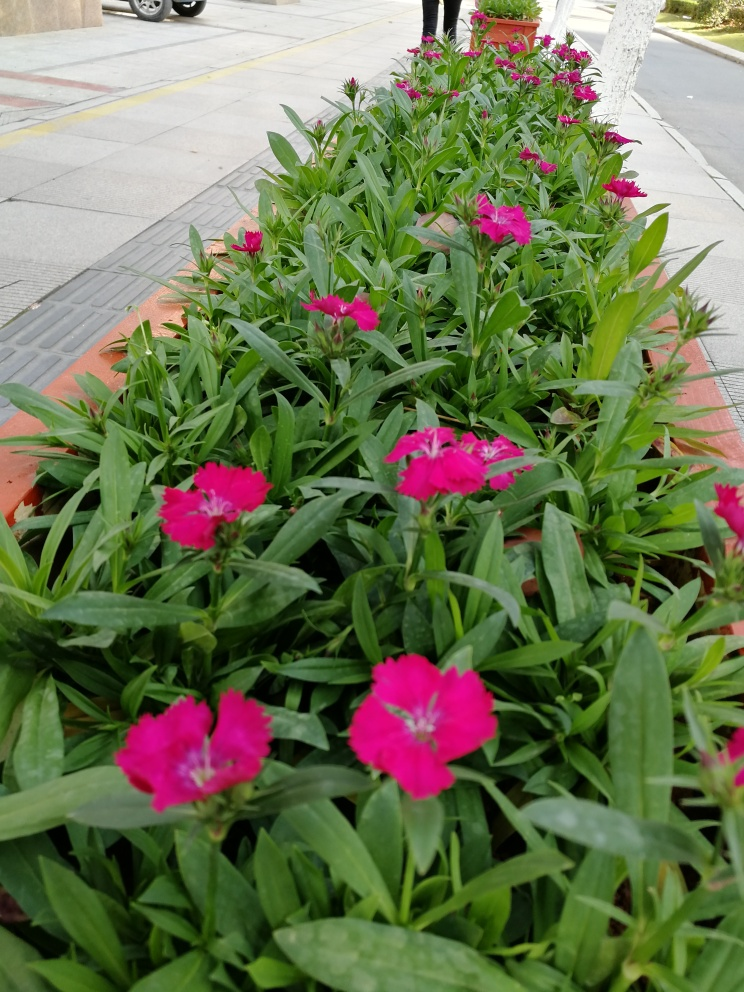Are there any quality issues with this image? Yes, there are a few quality issues with this image. The focus is soft on the flowers, which are not as sharp as they could be, indicating a slight blurriness. Also, the depth of field is shallow, which means that only a small section of the image is in focus while the rest is out of focus. Lastly, the composition could be improved to emphasize the blooms more effectively. 